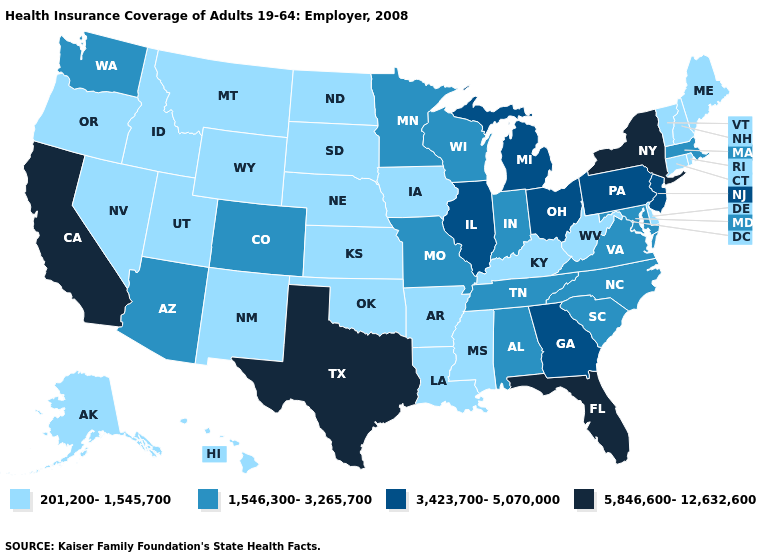Name the states that have a value in the range 1,546,300-3,265,700?
Answer briefly. Alabama, Arizona, Colorado, Indiana, Maryland, Massachusetts, Minnesota, Missouri, North Carolina, South Carolina, Tennessee, Virginia, Washington, Wisconsin. What is the value of South Dakota?
Be succinct. 201,200-1,545,700. Name the states that have a value in the range 3,423,700-5,070,000?
Be succinct. Georgia, Illinois, Michigan, New Jersey, Ohio, Pennsylvania. Which states hav the highest value in the MidWest?
Concise answer only. Illinois, Michigan, Ohio. What is the value of Vermont?
Give a very brief answer. 201,200-1,545,700. Name the states that have a value in the range 201,200-1,545,700?
Quick response, please. Alaska, Arkansas, Connecticut, Delaware, Hawaii, Idaho, Iowa, Kansas, Kentucky, Louisiana, Maine, Mississippi, Montana, Nebraska, Nevada, New Hampshire, New Mexico, North Dakota, Oklahoma, Oregon, Rhode Island, South Dakota, Utah, Vermont, West Virginia, Wyoming. What is the lowest value in the South?
Concise answer only. 201,200-1,545,700. Name the states that have a value in the range 1,546,300-3,265,700?
Concise answer only. Alabama, Arizona, Colorado, Indiana, Maryland, Massachusetts, Minnesota, Missouri, North Carolina, South Carolina, Tennessee, Virginia, Washington, Wisconsin. Among the states that border Washington , which have the highest value?
Quick response, please. Idaho, Oregon. Is the legend a continuous bar?
Keep it brief. No. What is the lowest value in states that border Tennessee?
Keep it brief. 201,200-1,545,700. What is the value of Maine?
Short answer required. 201,200-1,545,700. Does Massachusetts have a lower value than California?
Answer briefly. Yes. Among the states that border Tennessee , which have the lowest value?
Give a very brief answer. Arkansas, Kentucky, Mississippi. What is the lowest value in states that border Georgia?
Short answer required. 1,546,300-3,265,700. 